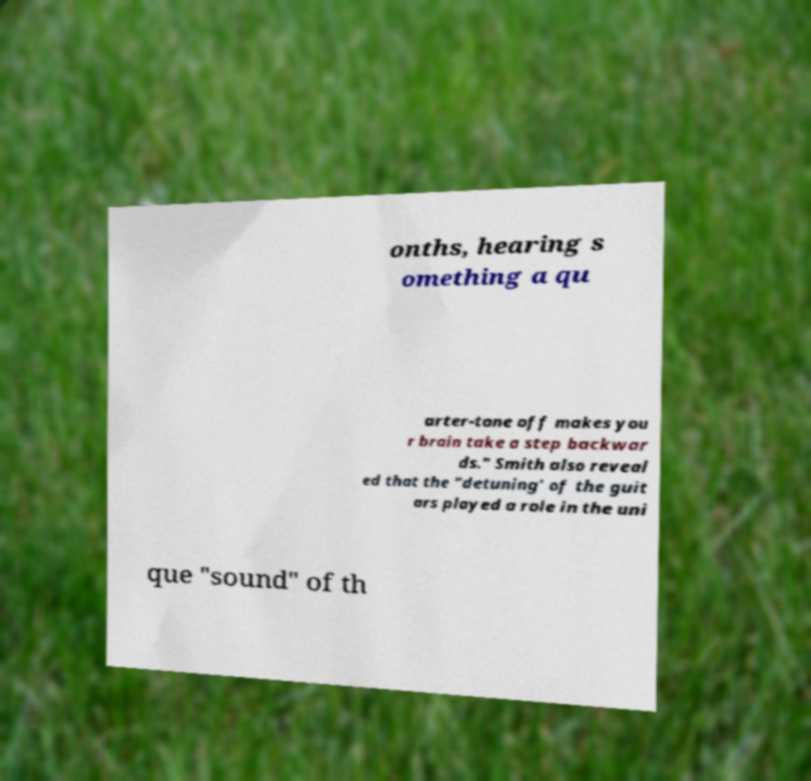Can you accurately transcribe the text from the provided image for me? onths, hearing s omething a qu arter-tone off makes you r brain take a step backwar ds." Smith also reveal ed that the "detuning' of the guit ars played a role in the uni que "sound" of th 